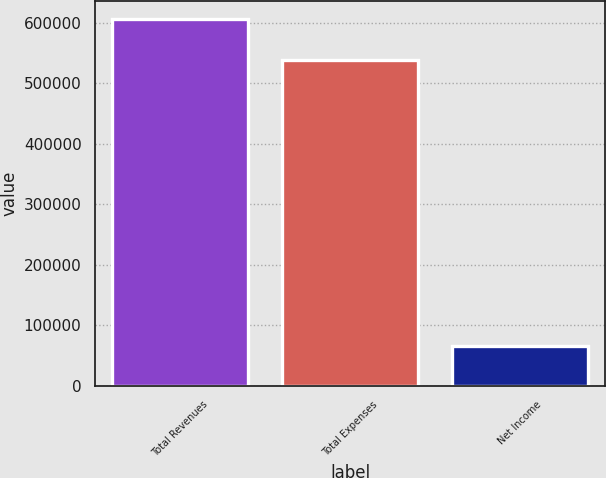<chart> <loc_0><loc_0><loc_500><loc_500><bar_chart><fcel>Total Revenues<fcel>Total Expenses<fcel>Net Income<nl><fcel>605293<fcel>538922<fcel>66371<nl></chart> 